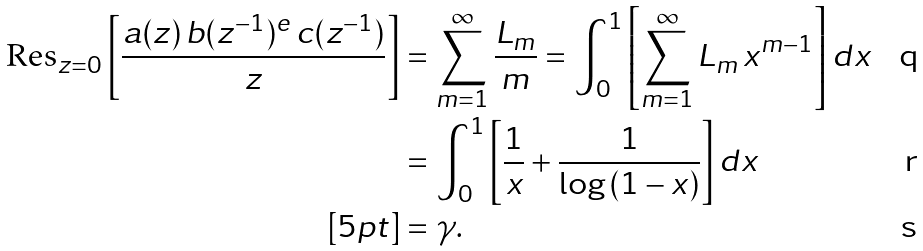Convert formula to latex. <formula><loc_0><loc_0><loc_500><loc_500>\text {Res} _ { z = 0 } \left [ \frac { a ( z ) \, b ( z ^ { - 1 } ) ^ { e } \, c ( z ^ { - 1 } ) } { z } \right ] & = \sum _ { m = 1 } ^ { \infty } \frac { L _ { m } } { m } = \int _ { 0 } ^ { 1 } \left [ \sum _ { m = 1 } ^ { \infty } L _ { m } \, x ^ { m - 1 } \right ] d x \\ & = \int _ { 0 } ^ { 1 } \left [ \frac { 1 } { x } + \frac { 1 } { \log \, ( 1 - x ) } \right ] d x \\ [ 5 p t ] & = \gamma .</formula> 